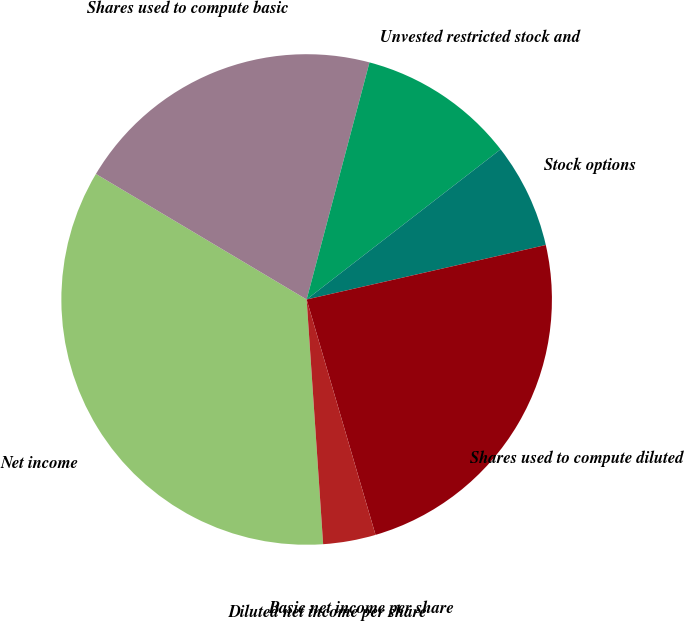Convert chart to OTSL. <chart><loc_0><loc_0><loc_500><loc_500><pie_chart><fcel>Net income<fcel>Shares used to compute basic<fcel>Unvested restricted stock and<fcel>Stock options<fcel>Shares used to compute diluted<fcel>Basic net income per share<fcel>Diluted net income per share<nl><fcel>34.62%<fcel>20.57%<fcel>10.39%<fcel>6.92%<fcel>24.03%<fcel>3.46%<fcel>0.0%<nl></chart> 